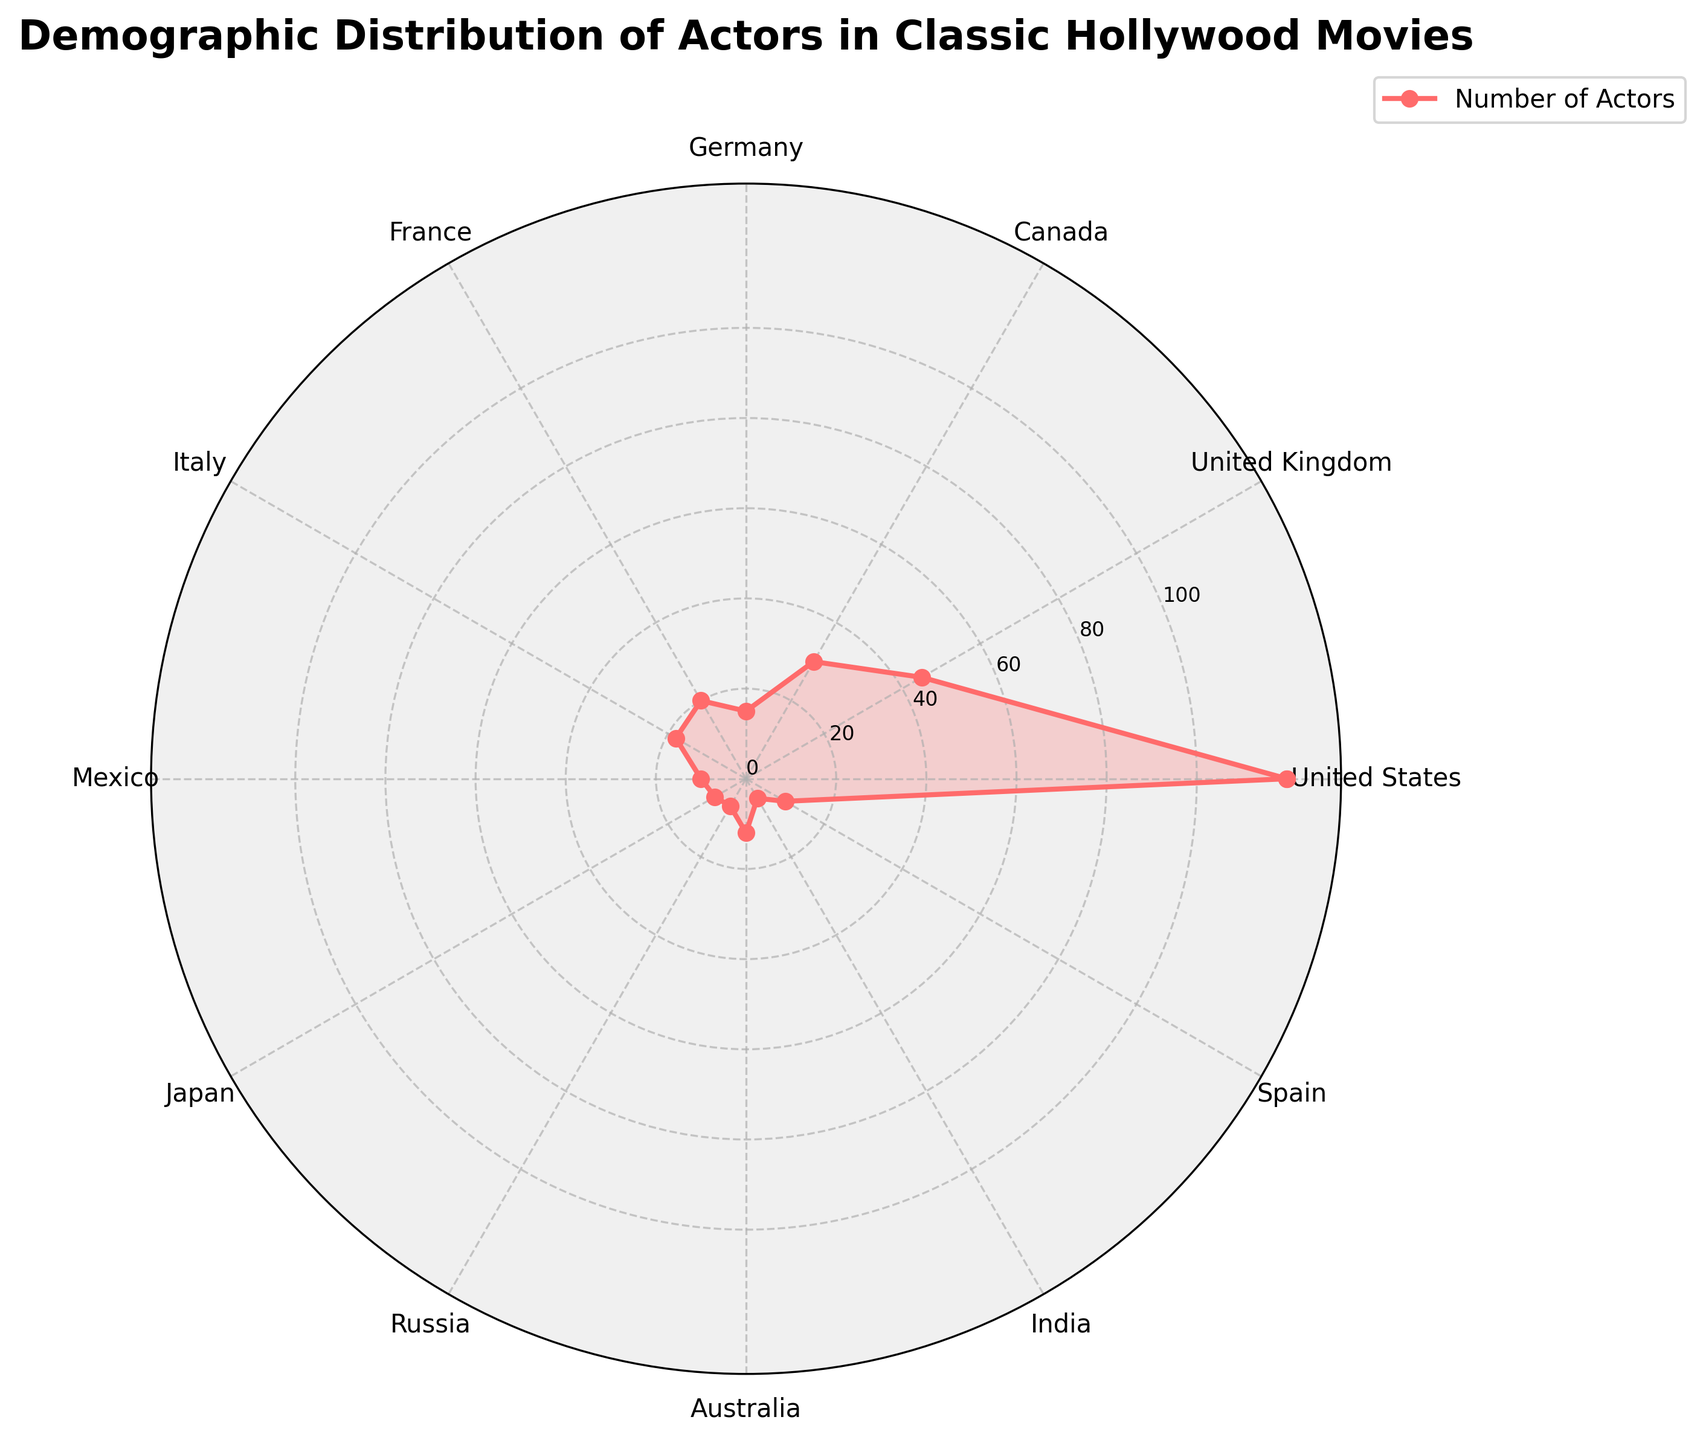what is the title of the plot? The title is usually placed at the top of the plot and is written in a bold and slightly larger font to easily draw attention. This plot's title should be evident at the top center of the figure.
Answer: Demographic Distribution of Actors in Classic Hollywood Movies Which country has the highest number of actors? By looking at the radial plot, the country with the outermost point from the center represents the country with the highest number of actors.
Answer: United States How many actors are from Italy and Spain combined? To find this total, you need to add the number of actors from Italy and Spain: 18 (Italy) + 10 (Spain) = 28.
Answer: 28 Which countries have more actors than Canada? By comparing all data points to Canada (30 actors), we can see that both the United States (120) and the United Kingdom (45) have more actors than Canada.
Answer: United States, United Kingdom What is the range of the number of actors in this plot? The range is calculated as the difference between the maximum and minimum values of actors: 120 (United States) - 5 (India) = 115.
Answer: 115 Which two countries have the smallest number of actors, and how many together? From the plot, the smallest points (closest to the center) represent these countries. India (5) and Russia (7) are the smallest, and combined, they sum up to: 5 + 7 = 12.
Answer: India and Russia, 12 What is the median number of actors among these countries? To find the median, list the number of actors in ascending order: 5, 7, 8, 10, 10, 12, 15, 18, 20, 30, 45, 120. The middle value in this ordered list is (12+15)/2 = 13.5.
Answer: 13.5 How many countries have at least 20 actors represented? By counting the number of data points at or above 20 in the plot, we identify four countries: United States (120), United Kingdom (45), Canada (30), and France (20).
Answer: Four countries Which continent is most represented among the actors? The most represented continent can be inferred by grouping countries into their respective continents and summing the number of actors: North America (US, Canada, Mexico), Europe (UK, Germany, France, Italy, Spain, Russia), Asia (Japan, India). North America has 120+30+10 = 160 actors.
Answer: North America 